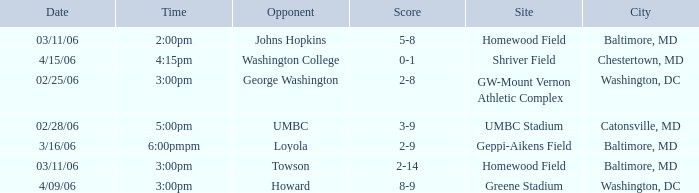Who was the Opponent at Homewood Field with a Score of 5-8? Johns Hopkins. 